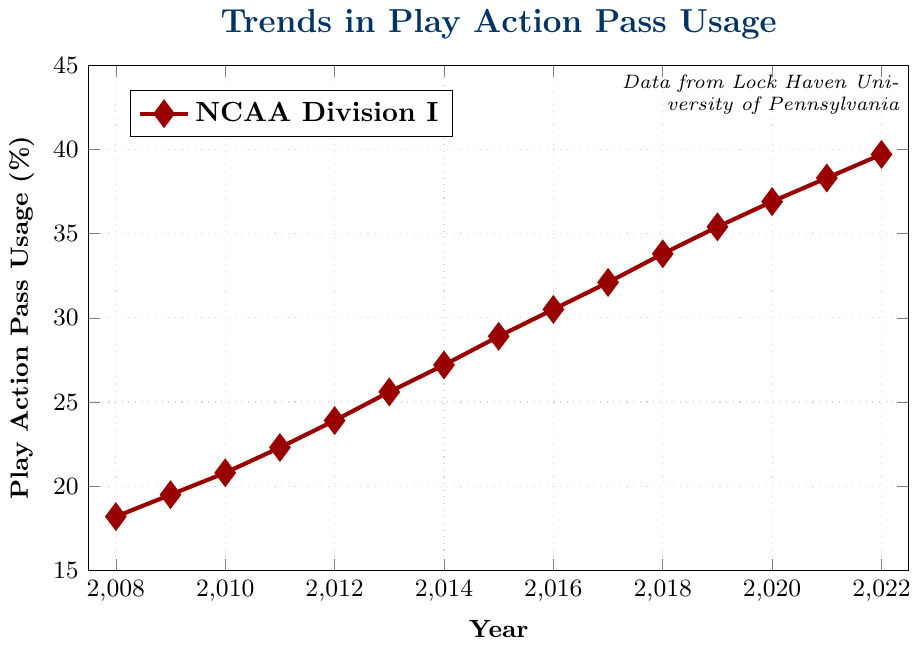What trend can be observed in Play Action Pass Usage from 2008 to 2022? The plot shows an increasing trend in Play Action Pass Usage over the years, starting at 18.2% in 2008 and reaching 39.7% in 2022. This upward trend highlights a consistent growth in the usage of Play Action Pass.
Answer: Increasing trend What is the difference in Play Action Pass Usage between the years 2008 and 2022? By looking at the values for 2008 and 2022 on the y-axis, we can see Play Action Pass Usage was 18.2% in 2008 and 39.7% in 2022. The difference is computed by subtracting the 2008 value from the 2022 value: 39.7 - 18.2 = 21.5%.
Answer: 21.5% During which year did the Play Action Pass Usage first exceed 30%? Observing the plot, we see that Play Action Pass Usage first exceeds 30% in 2016. In 2015, it was 28.9%, and in 2016 it increased to 30.5%.
Answer: 2016 In which year did the Play Action Pass Usage show the highest year-over-year increase? By calculating the year-over-year increases, we see the highest increase occurred between 2017 and 2018. The usage went from 32.1% to 33.8%, an increase of 1.7%.
Answer: 2017 to 2018 What is the average Play Action Pass Usage from 2010 to 2015? The years from 2010 to 2015 have these values: 20.8%, 22.3%, 23.9%, 25.6%, 27.2%, and 28.9%. Sum these values and divide by the number of years: (20.8 + 22.3 + 23.9 + 25.6 + 27.2 + 28.9) / 6 = 24.78%.
Answer: 24.78% How does the Play Action Pass Usage in 2012 compare visually to 2019? Observing the vertical position of the data markers for 2012 and 2019, 2012 (23.9%) is visually lower on the y-axis compared to 2019 (35.4%), indicating a substantial increase over these years.
Answer: 2012 is lower than 2019 Is there any year where the Play Action Pass Usage remained the same as the previous year? Examining the plot year by year, the Play Action Pass Usage increases each year without remaining constant. Therefore, there is no year where the usage remained the same as the previous year.
Answer: No What color represents the trend line for the Play Action Pass Usage? The trend line in the plot for Play Action Pass Usage is represented in red color.
Answer: Red 